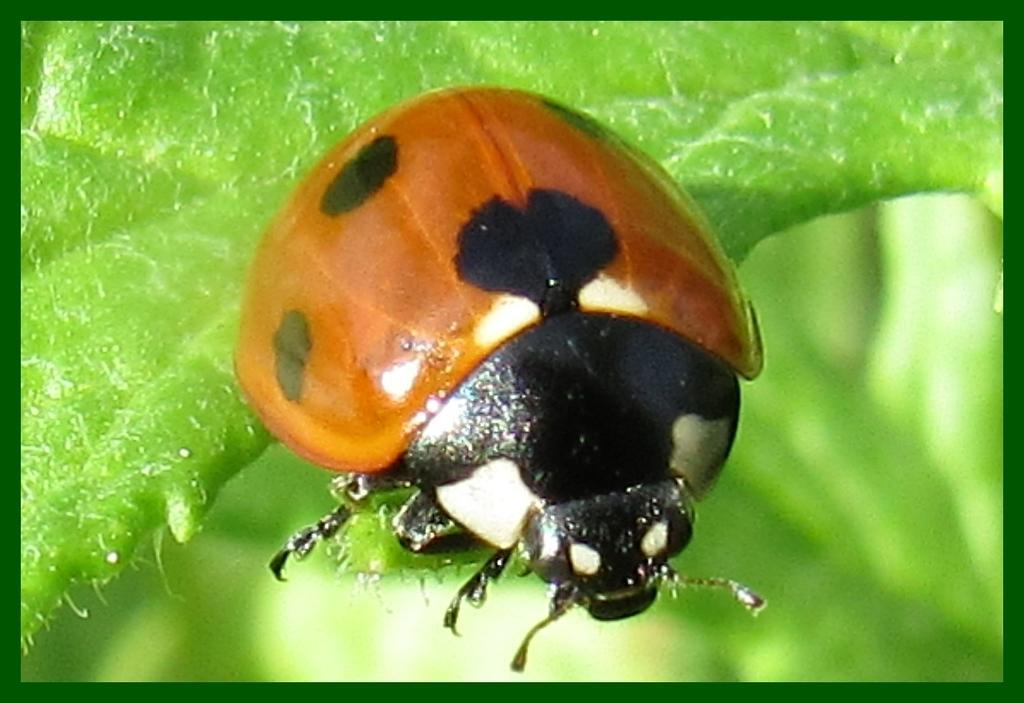Please provide a concise description of this image. There is a bug on a leaf. 